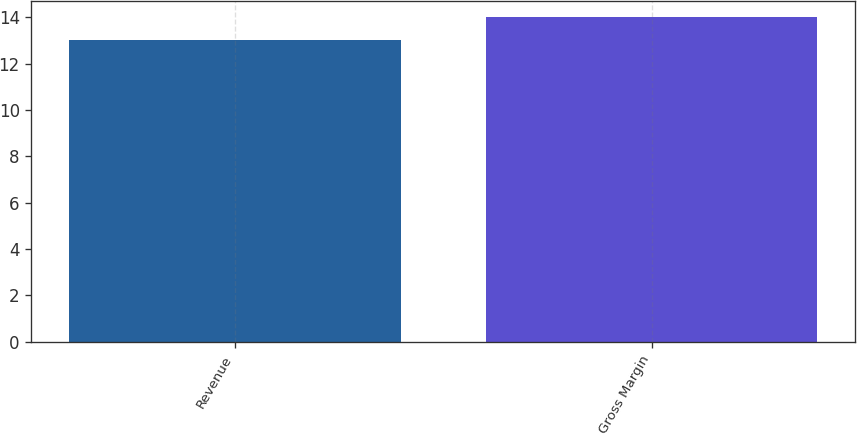<chart> <loc_0><loc_0><loc_500><loc_500><bar_chart><fcel>Revenue<fcel>Gross Margin<nl><fcel>13<fcel>14<nl></chart> 